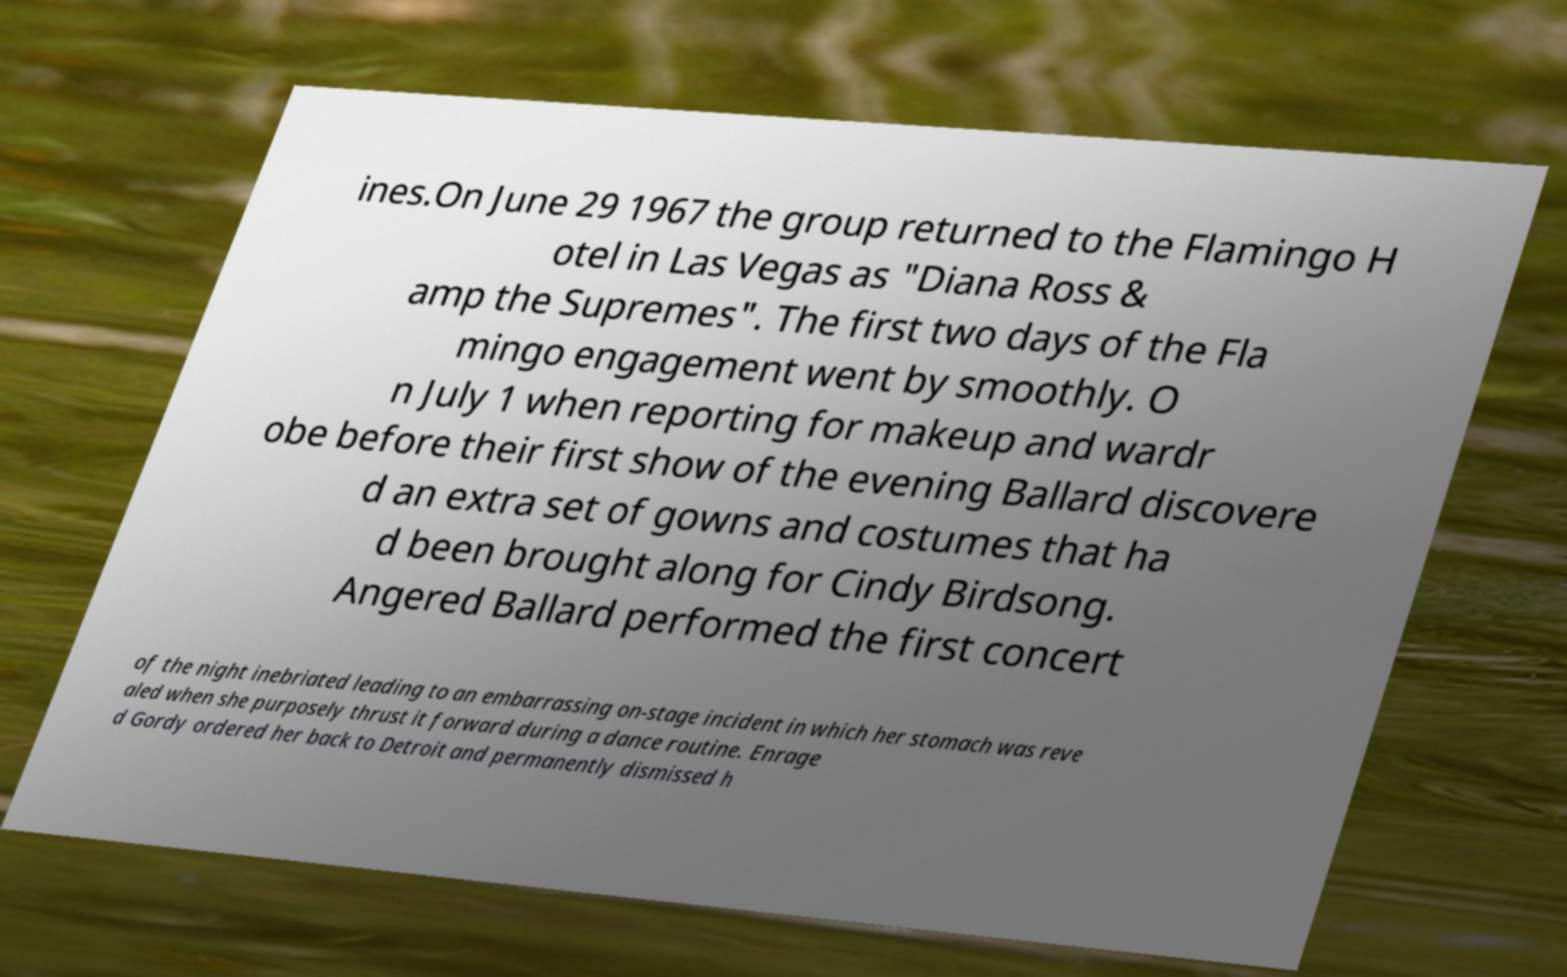For documentation purposes, I need the text within this image transcribed. Could you provide that? ines.On June 29 1967 the group returned to the Flamingo H otel in Las Vegas as "Diana Ross & amp the Supremes". The first two days of the Fla mingo engagement went by smoothly. O n July 1 when reporting for makeup and wardr obe before their first show of the evening Ballard discovere d an extra set of gowns and costumes that ha d been brought along for Cindy Birdsong. Angered Ballard performed the first concert of the night inebriated leading to an embarrassing on-stage incident in which her stomach was reve aled when she purposely thrust it forward during a dance routine. Enrage d Gordy ordered her back to Detroit and permanently dismissed h 